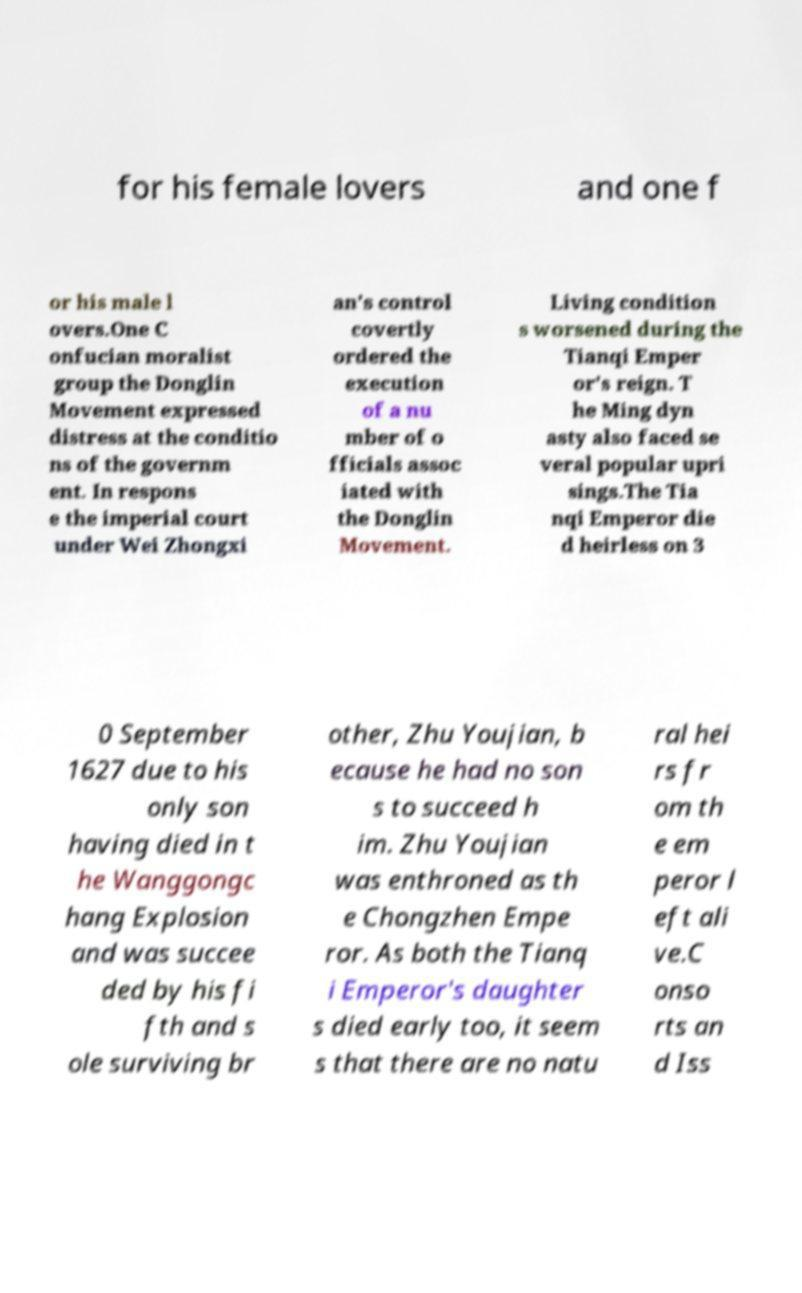Can you accurately transcribe the text from the provided image for me? for his female lovers and one f or his male l overs.One C onfucian moralist group the Donglin Movement expressed distress at the conditio ns of the governm ent. In respons e the imperial court under Wei Zhongxi an's control covertly ordered the execution of a nu mber of o fficials assoc iated with the Donglin Movement. Living condition s worsened during the Tianqi Emper or's reign. T he Ming dyn asty also faced se veral popular upri sings.The Tia nqi Emperor die d heirless on 3 0 September 1627 due to his only son having died in t he Wanggongc hang Explosion and was succee ded by his fi fth and s ole surviving br other, Zhu Youjian, b ecause he had no son s to succeed h im. Zhu Youjian was enthroned as th e Chongzhen Empe ror. As both the Tianq i Emperor's daughter s died early too, it seem s that there are no natu ral hei rs fr om th e em peror l eft ali ve.C onso rts an d Iss 